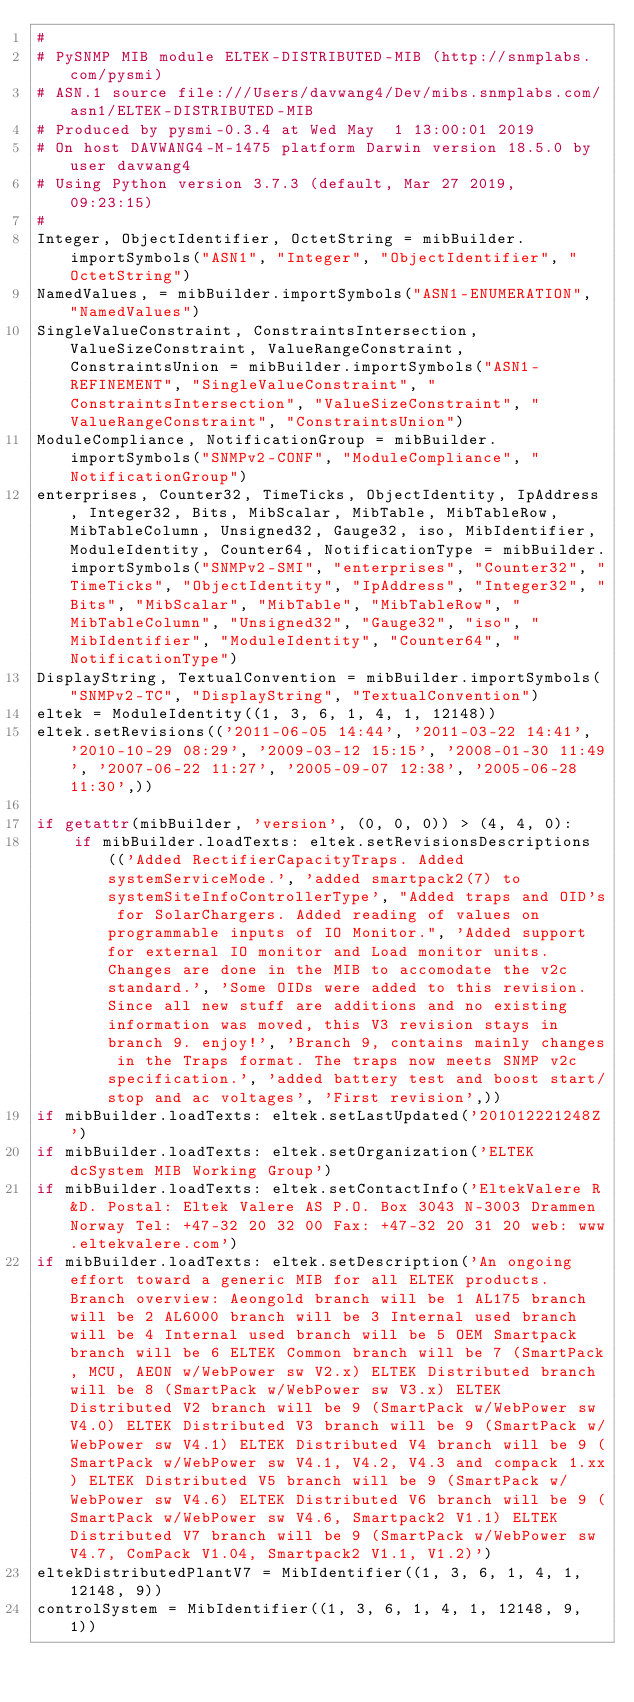Convert code to text. <code><loc_0><loc_0><loc_500><loc_500><_Python_>#
# PySNMP MIB module ELTEK-DISTRIBUTED-MIB (http://snmplabs.com/pysmi)
# ASN.1 source file:///Users/davwang4/Dev/mibs.snmplabs.com/asn1/ELTEK-DISTRIBUTED-MIB
# Produced by pysmi-0.3.4 at Wed May  1 13:00:01 2019
# On host DAVWANG4-M-1475 platform Darwin version 18.5.0 by user davwang4
# Using Python version 3.7.3 (default, Mar 27 2019, 09:23:15) 
#
Integer, ObjectIdentifier, OctetString = mibBuilder.importSymbols("ASN1", "Integer", "ObjectIdentifier", "OctetString")
NamedValues, = mibBuilder.importSymbols("ASN1-ENUMERATION", "NamedValues")
SingleValueConstraint, ConstraintsIntersection, ValueSizeConstraint, ValueRangeConstraint, ConstraintsUnion = mibBuilder.importSymbols("ASN1-REFINEMENT", "SingleValueConstraint", "ConstraintsIntersection", "ValueSizeConstraint", "ValueRangeConstraint", "ConstraintsUnion")
ModuleCompliance, NotificationGroup = mibBuilder.importSymbols("SNMPv2-CONF", "ModuleCompliance", "NotificationGroup")
enterprises, Counter32, TimeTicks, ObjectIdentity, IpAddress, Integer32, Bits, MibScalar, MibTable, MibTableRow, MibTableColumn, Unsigned32, Gauge32, iso, MibIdentifier, ModuleIdentity, Counter64, NotificationType = mibBuilder.importSymbols("SNMPv2-SMI", "enterprises", "Counter32", "TimeTicks", "ObjectIdentity", "IpAddress", "Integer32", "Bits", "MibScalar", "MibTable", "MibTableRow", "MibTableColumn", "Unsigned32", "Gauge32", "iso", "MibIdentifier", "ModuleIdentity", "Counter64", "NotificationType")
DisplayString, TextualConvention = mibBuilder.importSymbols("SNMPv2-TC", "DisplayString", "TextualConvention")
eltek = ModuleIdentity((1, 3, 6, 1, 4, 1, 12148))
eltek.setRevisions(('2011-06-05 14:44', '2011-03-22 14:41', '2010-10-29 08:29', '2009-03-12 15:15', '2008-01-30 11:49', '2007-06-22 11:27', '2005-09-07 12:38', '2005-06-28 11:30',))

if getattr(mibBuilder, 'version', (0, 0, 0)) > (4, 4, 0):
    if mibBuilder.loadTexts: eltek.setRevisionsDescriptions(('Added RectifierCapacityTraps. Added systemServiceMode.', 'added smartpack2(7) to systemSiteInfoControllerType', "Added traps and OID's for SolarChargers. Added reading of values on programmable inputs of IO Monitor.", 'Added support for external IO monitor and Load monitor units. Changes are done in the MIB to accomodate the v2c standard.', 'Some OIDs were added to this revision. Since all new stuff are additions and no existing information was moved, this V3 revision stays in branch 9. enjoy!', 'Branch 9, contains mainly changes in the Traps format. The traps now meets SNMP v2c specification.', 'added battery test and boost start/stop and ac voltages', 'First revision',))
if mibBuilder.loadTexts: eltek.setLastUpdated('201012221248Z')
if mibBuilder.loadTexts: eltek.setOrganization('ELTEK dcSystem MIB Working Group')
if mibBuilder.loadTexts: eltek.setContactInfo('EltekValere R&D. Postal: Eltek Valere AS P.O. Box 3043 N-3003 Drammen Norway Tel: +47-32 20 32 00 Fax: +47-32 20 31 20 web: www.eltekvalere.com')
if mibBuilder.loadTexts: eltek.setDescription('An ongoing effort toward a generic MIB for all ELTEK products. Branch overview: Aeongold branch will be 1 AL175 branch will be 2 AL6000 branch will be 3 Internal used branch will be 4 Internal used branch will be 5 OEM Smartpack branch will be 6 ELTEK Common branch will be 7 (SmartPack, MCU, AEON w/WebPower sw V2.x) ELTEK Distributed branch will be 8 (SmartPack w/WebPower sw V3.x) ELTEK Distributed V2 branch will be 9 (SmartPack w/WebPower sw V4.0) ELTEK Distributed V3 branch will be 9 (SmartPack w/WebPower sw V4.1) ELTEK Distributed V4 branch will be 9 (SmartPack w/WebPower sw V4.1, V4.2, V4.3 and compack 1.xx) ELTEK Distributed V5 branch will be 9 (SmartPack w/WebPower sw V4.6) ELTEK Distributed V6 branch will be 9 (SmartPack w/WebPower sw V4.6, Smartpack2 V1.1) ELTEK Distributed V7 branch will be 9 (SmartPack w/WebPower sw V4.7, ComPack V1.04, Smartpack2 V1.1, V1.2)')
eltekDistributedPlantV7 = MibIdentifier((1, 3, 6, 1, 4, 1, 12148, 9))
controlSystem = MibIdentifier((1, 3, 6, 1, 4, 1, 12148, 9, 1))</code> 